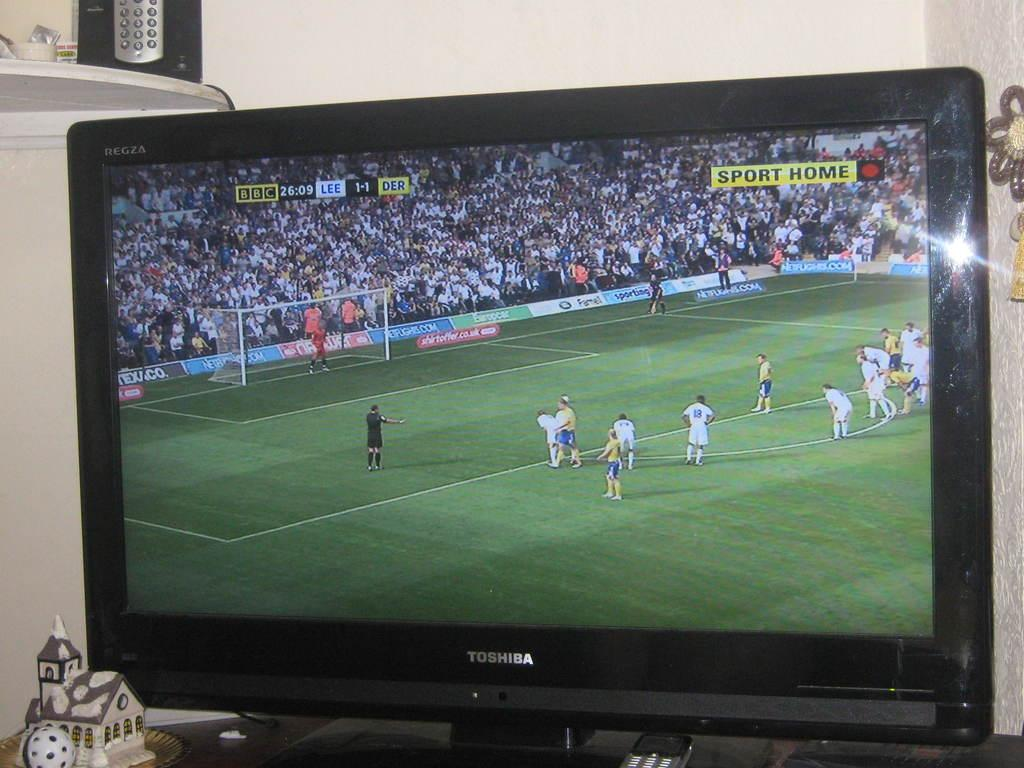<image>
Render a clear and concise summary of the photo. A soccer game is being shown on the Toshiba television. 